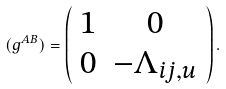<formula> <loc_0><loc_0><loc_500><loc_500>( g ^ { A B } ) = \left ( \begin{array} { c c } 1 & 0 \\ 0 & - \Lambda _ { i j , u } \end{array} \right ) .</formula> 